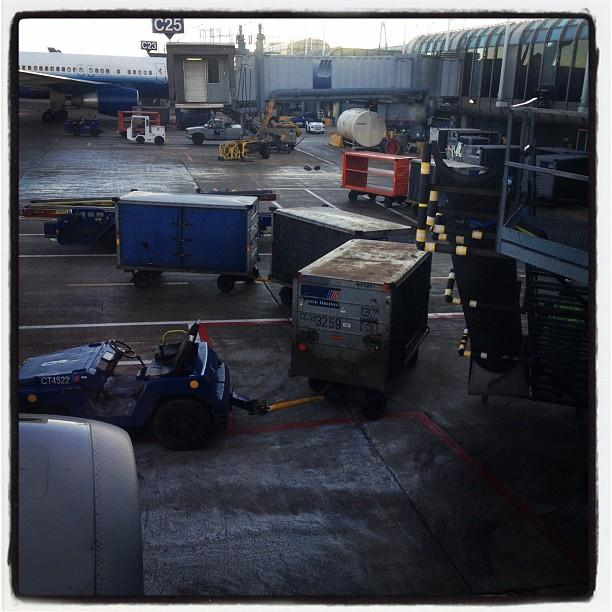What is the blue vehicle doing? pulling carts 